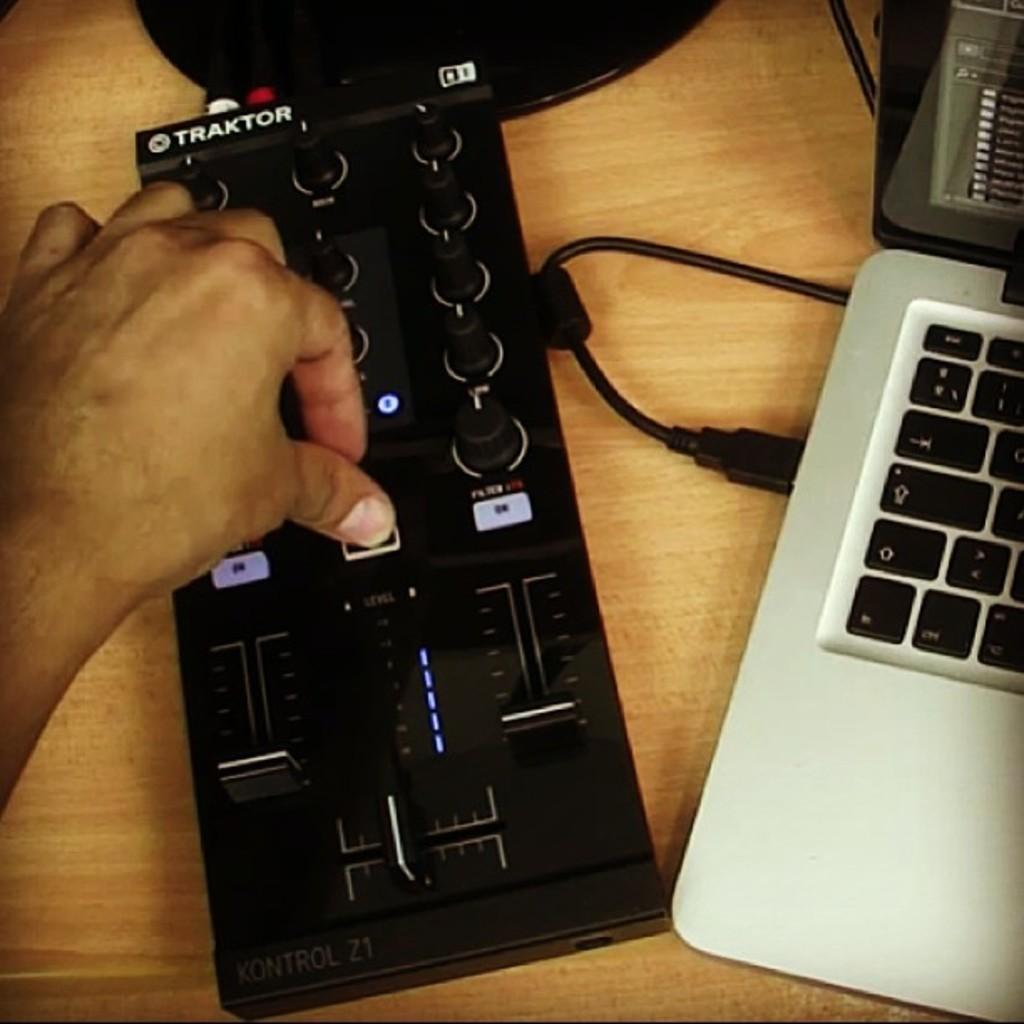<image>
Write a terse but informative summary of the picture. A person is hitting a remote control button and the remote says TRAKTOR on it. 